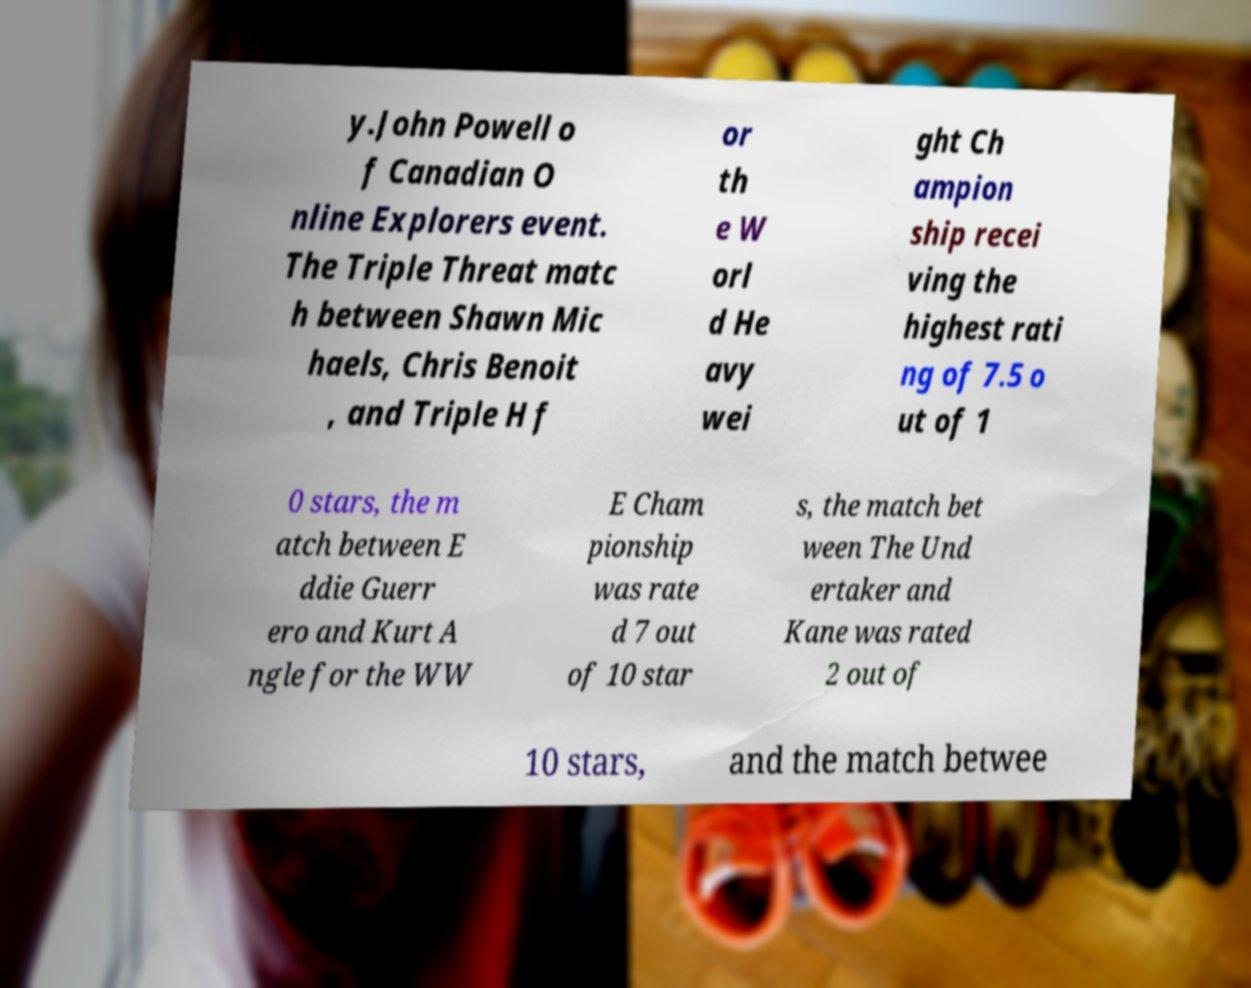Could you assist in decoding the text presented in this image and type it out clearly? y.John Powell o f Canadian O nline Explorers event. The Triple Threat matc h between Shawn Mic haels, Chris Benoit , and Triple H f or th e W orl d He avy wei ght Ch ampion ship recei ving the highest rati ng of 7.5 o ut of 1 0 stars, the m atch between E ddie Guerr ero and Kurt A ngle for the WW E Cham pionship was rate d 7 out of 10 star s, the match bet ween The Und ertaker and Kane was rated 2 out of 10 stars, and the match betwee 